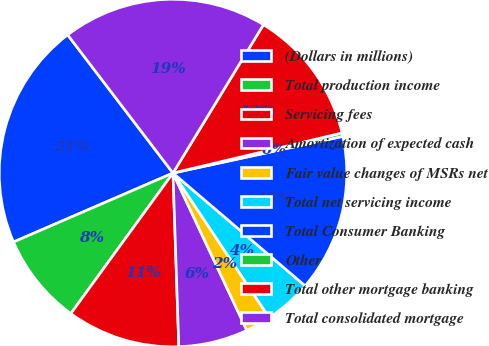Convert chart to OTSL. <chart><loc_0><loc_0><loc_500><loc_500><pie_chart><fcel>(Dollars in millions)<fcel>Total production income<fcel>Servicing fees<fcel>Amortization of expected cash<fcel>Fair value changes of MSRs net<fcel>Total net servicing income<fcel>Total Consumer Banking<fcel>Other<fcel>Total other mortgage banking<fcel>Total consolidated mortgage<nl><fcel>21.13%<fcel>8.5%<fcel>10.54%<fcel>6.45%<fcel>2.36%<fcel>4.41%<fcel>14.63%<fcel>0.32%<fcel>12.58%<fcel>19.08%<nl></chart> 